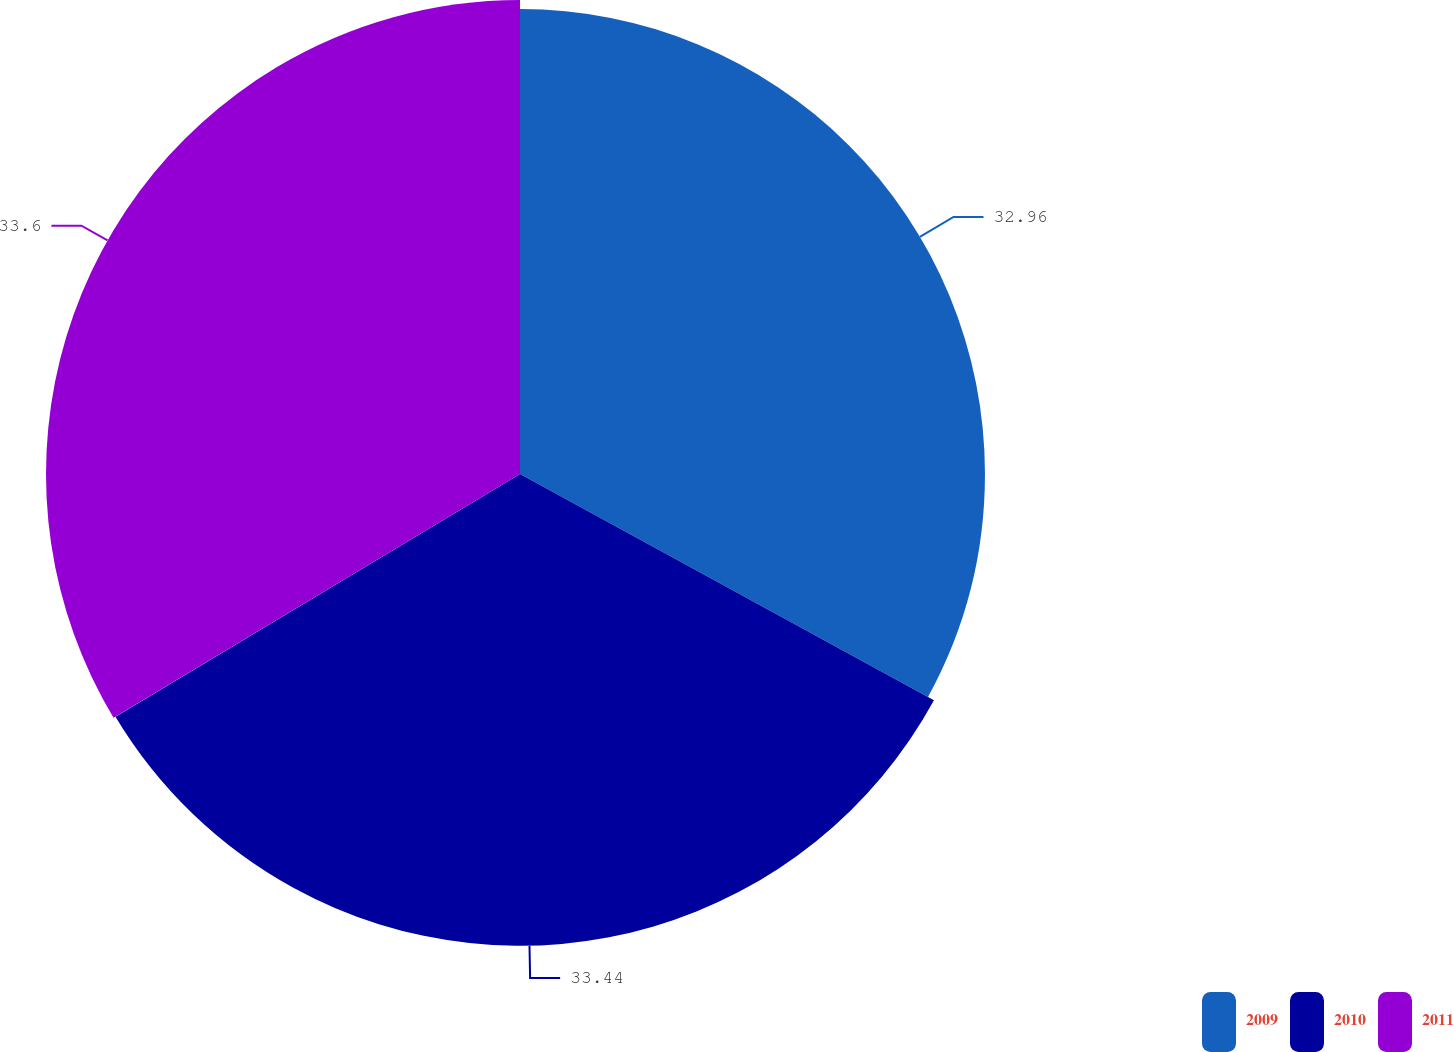Convert chart to OTSL. <chart><loc_0><loc_0><loc_500><loc_500><pie_chart><fcel>2009<fcel>2010<fcel>2011<nl><fcel>32.96%<fcel>33.44%<fcel>33.6%<nl></chart> 